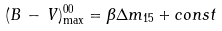<formula> <loc_0><loc_0><loc_500><loc_500>( B \, - \, V ) ^ { 0 0 } _ { \max } = \beta \Delta m _ { 1 5 } + c o n s t</formula> 